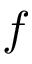Convert formula to latex. <formula><loc_0><loc_0><loc_500><loc_500>f</formula> 